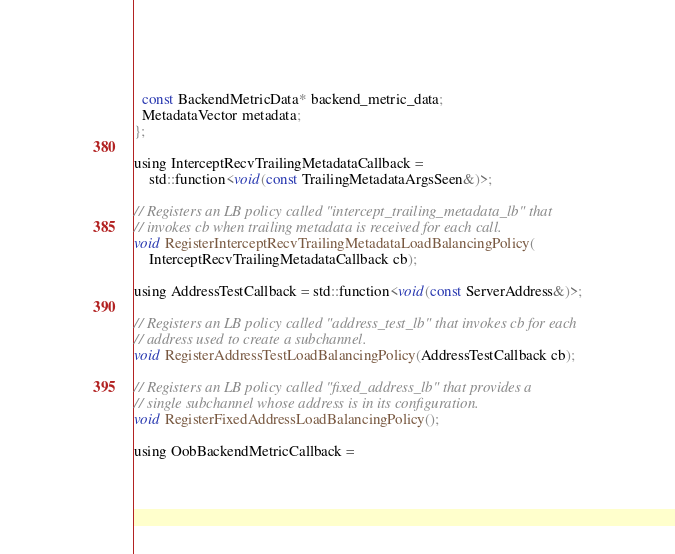<code> <loc_0><loc_0><loc_500><loc_500><_C_>  const BackendMetricData* backend_metric_data;
  MetadataVector metadata;
};

using InterceptRecvTrailingMetadataCallback =
    std::function<void(const TrailingMetadataArgsSeen&)>;

// Registers an LB policy called "intercept_trailing_metadata_lb" that
// invokes cb when trailing metadata is received for each call.
void RegisterInterceptRecvTrailingMetadataLoadBalancingPolicy(
    InterceptRecvTrailingMetadataCallback cb);

using AddressTestCallback = std::function<void(const ServerAddress&)>;

// Registers an LB policy called "address_test_lb" that invokes cb for each
// address used to create a subchannel.
void RegisterAddressTestLoadBalancingPolicy(AddressTestCallback cb);

// Registers an LB policy called "fixed_address_lb" that provides a
// single subchannel whose address is in its configuration.
void RegisterFixedAddressLoadBalancingPolicy();

using OobBackendMetricCallback =</code> 